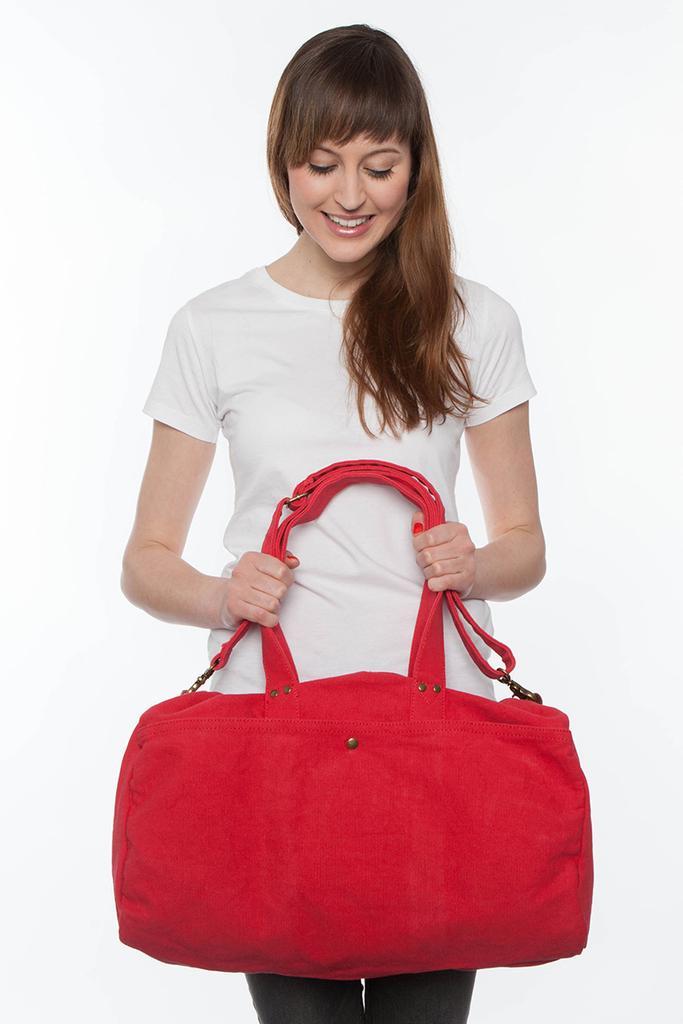Could you give a brief overview of what you see in this image? In this picture, there is a woman, wearing a white T-shirt, holding a red color bag in her hands. 